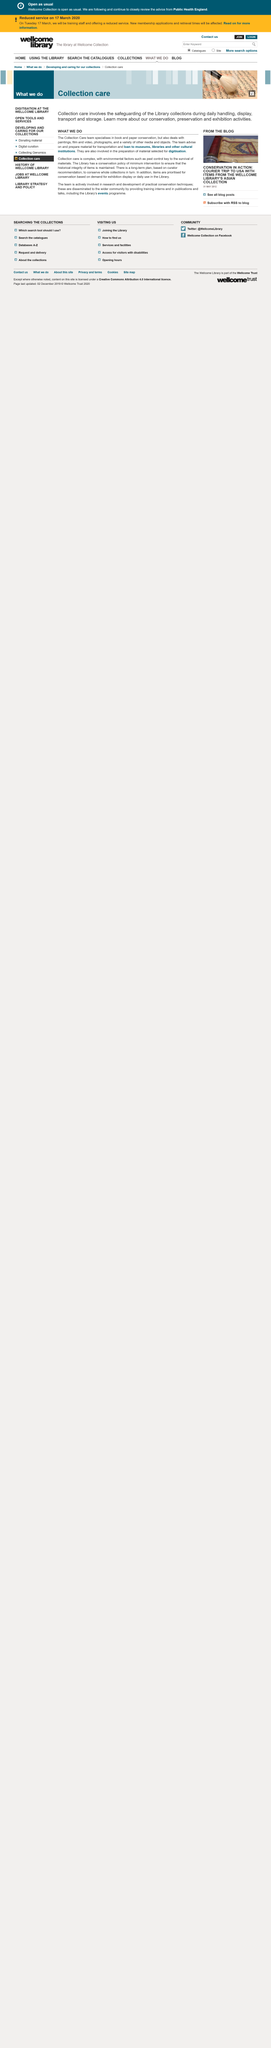Give some essential details in this illustration. The Collection Care team specializes in book and paper conservation. The Library's policy regarding conservation is to minimize intervention in order to preserve the historical integrity of items. The Collection Care team conserves a variety of media and objects. 